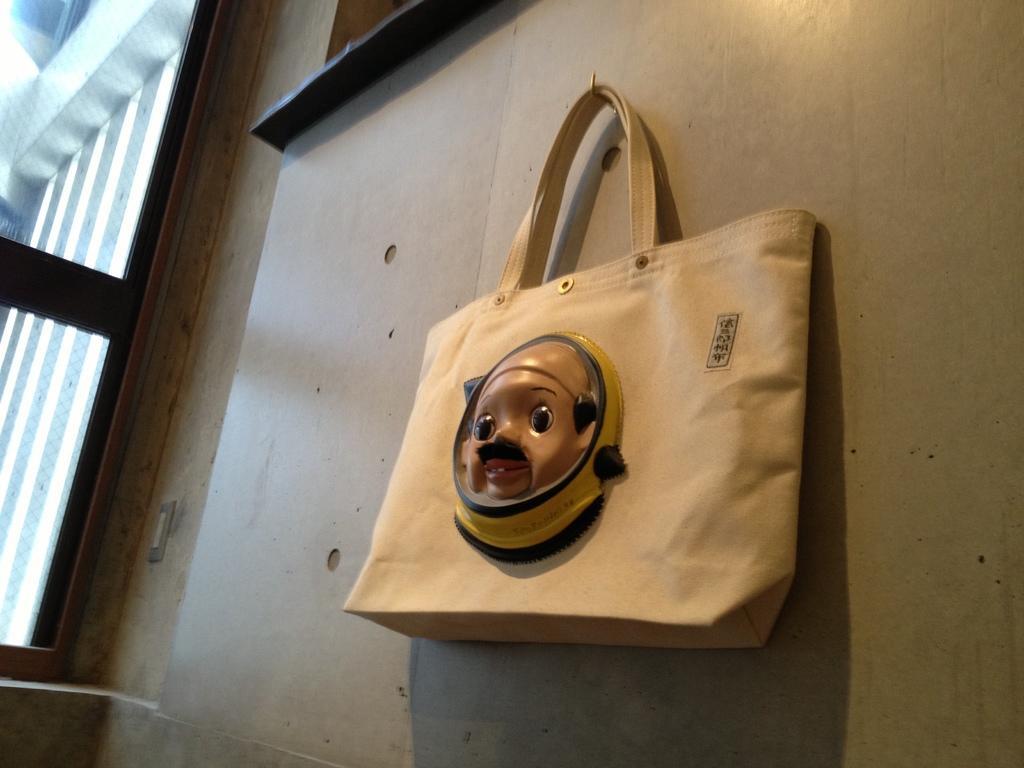In one or two sentences, can you explain what this image depicts? In this image there is a bag hanging to the wall. At the back there is a door. 